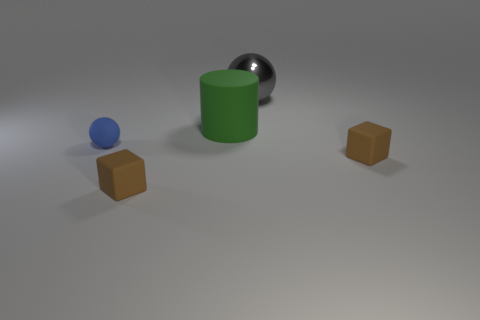What color is the small rubber block left of the shiny ball?
Provide a short and direct response. Brown. Is the size of the brown object that is to the left of the green rubber object the same as the gray metal thing?
Make the answer very short. No. There is a blue rubber object that is the same shape as the large gray object; what is its size?
Your answer should be very brief. Small. Are there any other things that are the same size as the shiny object?
Your answer should be very brief. Yes. Is the shape of the large green matte thing the same as the gray metal object?
Make the answer very short. No. Is the number of large gray objects in front of the large green cylinder less than the number of big metal objects left of the matte sphere?
Your answer should be compact. No. How many brown things are in front of the green matte cylinder?
Make the answer very short. 2. There is a rubber object behind the small ball; is its shape the same as the brown object that is to the right of the matte cylinder?
Ensure brevity in your answer.  No. How many other objects are there of the same color as the tiny rubber ball?
Provide a short and direct response. 0. There is a sphere right of the brown matte object on the left side of the matte object behind the small sphere; what is it made of?
Your response must be concise. Metal. 